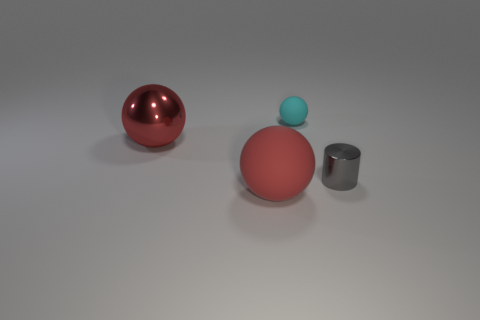Is the number of gray shiny things less than the number of big objects?
Your answer should be very brief. Yes. There is a metallic thing left of the cyan rubber object; is its shape the same as the metallic thing that is on the right side of the red matte ball?
Your answer should be very brief. No. How many things are large red metal blocks or big red things?
Offer a very short reply. 2. The shiny cylinder that is the same size as the cyan matte sphere is what color?
Keep it short and to the point. Gray. What number of big red metallic objects are to the right of the big sphere that is in front of the gray cylinder?
Your answer should be very brief. 0. What number of rubber balls are both on the left side of the cyan matte thing and on the right side of the big red matte object?
Your answer should be very brief. 0. How many things are either tiny metallic things that are behind the red rubber sphere or tiny objects right of the cyan matte thing?
Make the answer very short. 1. What is the shape of the metal thing that is left of the matte sphere that is to the right of the big rubber ball?
Your answer should be compact. Sphere. There is a metal object to the left of the large red rubber sphere; is it the same color as the rubber object that is on the left side of the tiny cyan matte sphere?
Offer a terse response. Yes. Is there any other thing of the same color as the cylinder?
Your answer should be very brief. No. 